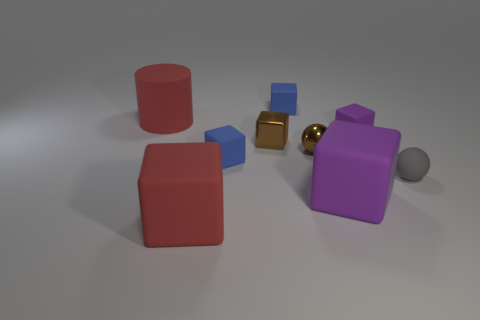Subtract all small blue blocks. How many blocks are left? 4 Subtract all blue blocks. How many blocks are left? 4 Subtract 2 cubes. How many cubes are left? 4 Subtract all brown blocks. Subtract all yellow cylinders. How many blocks are left? 5 Subtract all cylinders. How many objects are left? 8 Add 7 large cyan metallic cylinders. How many large cyan metallic cylinders exist? 7 Subtract 0 yellow balls. How many objects are left? 9 Subtract all large purple matte things. Subtract all blue blocks. How many objects are left? 6 Add 2 big red cylinders. How many big red cylinders are left? 3 